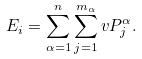<formula> <loc_0><loc_0><loc_500><loc_500>E _ { i } = \sum _ { \alpha = 1 } ^ { n } \sum _ { j = 1 } ^ { m _ { \alpha } } v P _ { j } ^ { \alpha } .</formula> 